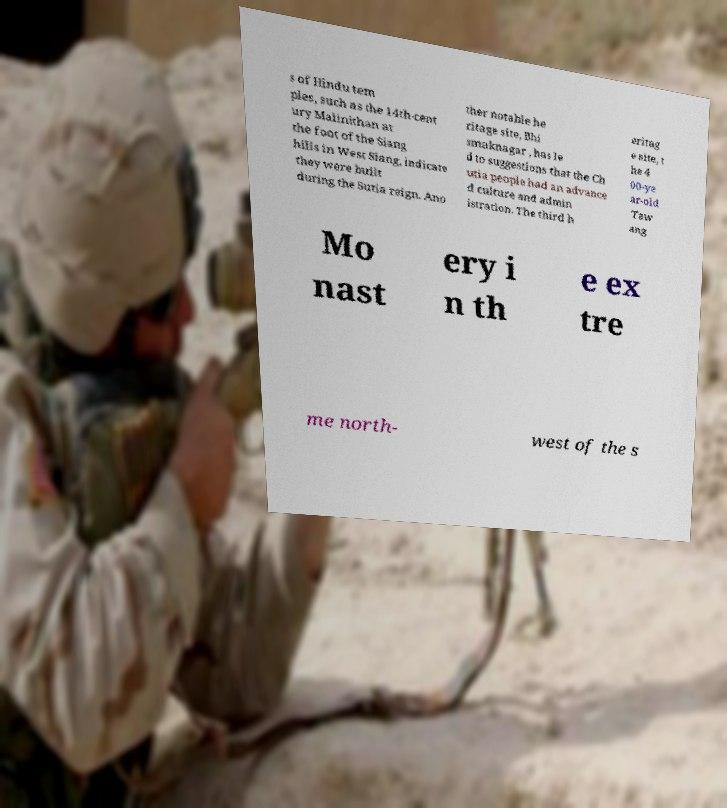I need the written content from this picture converted into text. Can you do that? s of Hindu tem ples, such as the 14th-cent ury Malinithan at the foot of the Siang hills in West Siang, indicate they were built during the Sutia reign. Ano ther notable he ritage site, Bhi smaknagar , has le d to suggestions that the Ch utia people had an advance d culture and admin istration. The third h eritag e site, t he 4 00-ye ar-old Taw ang Mo nast ery i n th e ex tre me north- west of the s 